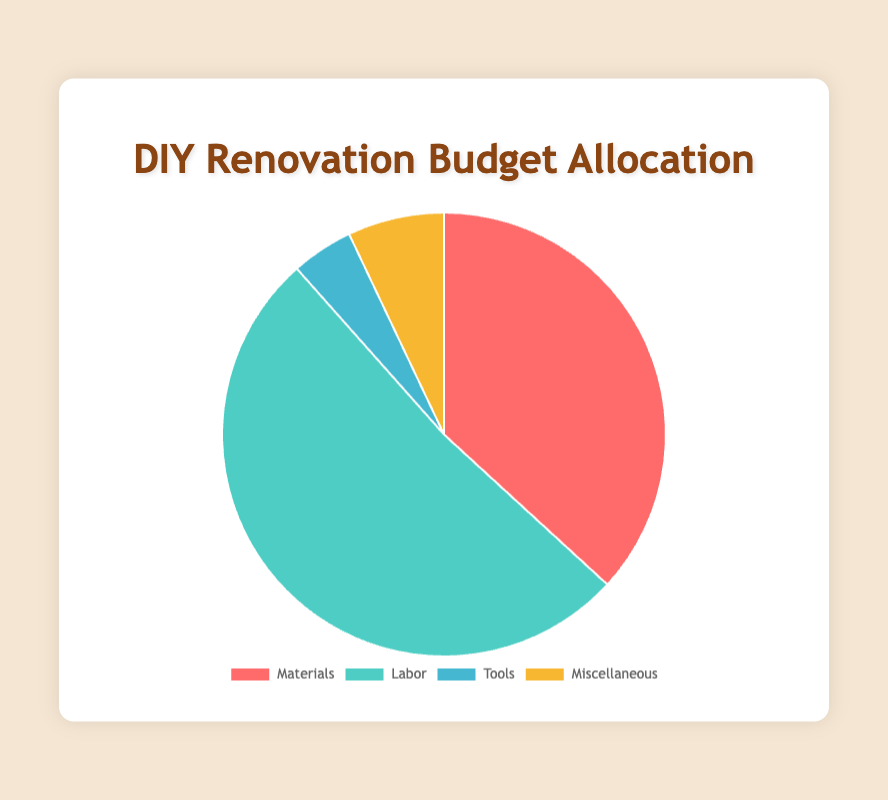What is the total budget allocated for Materials and Labor combined? First, look at the total amounts for Materials ($10,200) and Labor ($14,300). Add these two amounts together to get the combined budget. So, $10,200 + $14,300 = $24,500.
Answer: $24,500 Which category has the highest budget allocation? Compare the budget values of all four categories: Materials ($10,200), Labor ($14,300), Tools ($1,250), and Miscellaneous ($1,950). Labor has the highest budget allocation at $14,300.
Answer: Labor What percentage of the total budget is allocated to Tools? Find the total budget by summing up all categories: $10,200 (Materials) + $14,300 (Labor) + $1,250 (Tools) + $1,950 (Miscellaneous) = $27,700. The percentage for Tools is calculated by ($1,250 / $27,700) * 100 ≈ 4.5%.
Answer: 4.5% How much more is allocated to Labor compared to Miscellaneous? Subtract the Miscellaneous budget from the Labor budget: $14,300 (Labor) - $1,950 (Miscellaneous) = $12,350.
Answer: $12,350 What is the smallest category in terms of budget allocation? Compare the budget values of all four categories: Materials ($10,200), Labor ($14,300), Tools ($1,250), and Miscellaneous ($1,950). Tools has the smallest budget allocation at $1,250.
Answer: Tools What is the average budget allocation across all categories? Find the total budget by summing all categories: $10,200 (Materials) + $14,300 (Labor) + $1,250 (Tools) + $1,950 (Miscellaneous) = $27,700. Then divide by the number of categories (4). So, $27,700 / 4 = $6,925.
Answer: $6,925 How many times larger is the budget for Labor compared to Tools? Divide the Labor budget by the Tools budget: $14,300 (Labor) / $1,250 (Tools) ≈ 11.44.
Answer: 11.44 times What is the combined budget for Tools and Miscellaneous? Add the amounts for Tools ($1,250) and Miscellaneous ($1,950) together: $1,250 + $1,950 = $3,200.
Answer: $3,200 What percentage of the total budget is allocated to Labor? Calculate the total budget: $10,200 (Materials) + $14,300 (Labor) + $1,250 (Tools) + $1,950 (Miscellaneous) = $27,700. The percentage for Labor is ($14,300 / $27,700) * 100 ≈ 51.6%.
Answer: 51.6% Which category has a larger budget, Materials or Miscellaneous? Compare the amounts: Materials ($10,200) and Miscellaneous ($1,950). Materials has a larger budget allocation.
Answer: Materials 